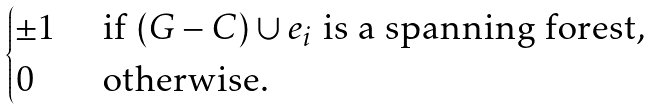Convert formula to latex. <formula><loc_0><loc_0><loc_500><loc_500>\begin{cases} \pm 1 & \text { if } ( G - C ) \cup e _ { i } \text { is a spanning forest,} \\ 0 & \text { otherwise.} \end{cases}</formula> 